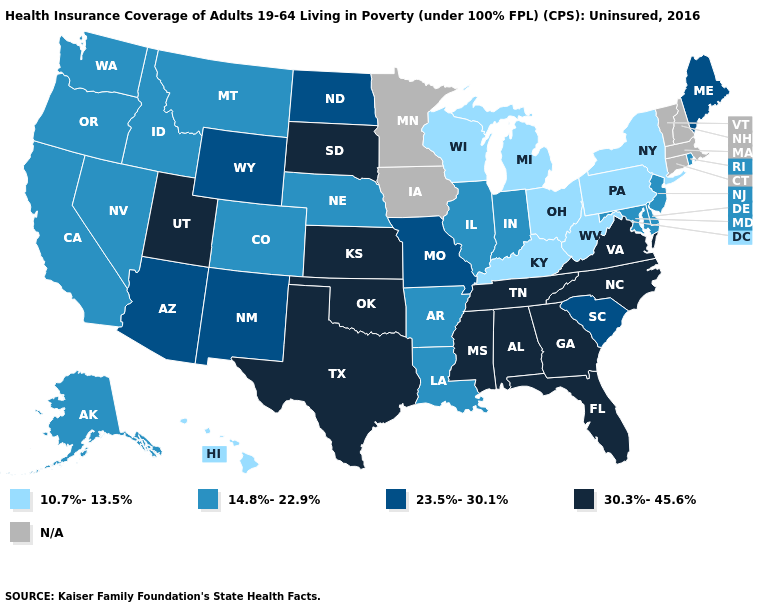What is the highest value in the USA?
Be succinct. 30.3%-45.6%. Does Alaska have the highest value in the USA?
Short answer required. No. Name the states that have a value in the range 10.7%-13.5%?
Write a very short answer. Hawaii, Kentucky, Michigan, New York, Ohio, Pennsylvania, West Virginia, Wisconsin. What is the value of Michigan?
Concise answer only. 10.7%-13.5%. What is the value of Kansas?
Give a very brief answer. 30.3%-45.6%. Name the states that have a value in the range 10.7%-13.5%?
Answer briefly. Hawaii, Kentucky, Michigan, New York, Ohio, Pennsylvania, West Virginia, Wisconsin. Among the states that border Texas , which have the lowest value?
Give a very brief answer. Arkansas, Louisiana. What is the highest value in states that border Connecticut?
Answer briefly. 14.8%-22.9%. Name the states that have a value in the range 23.5%-30.1%?
Quick response, please. Arizona, Maine, Missouri, New Mexico, North Dakota, South Carolina, Wyoming. Does Utah have the highest value in the West?
Be succinct. Yes. What is the lowest value in the USA?
Short answer required. 10.7%-13.5%. Name the states that have a value in the range 30.3%-45.6%?
Quick response, please. Alabama, Florida, Georgia, Kansas, Mississippi, North Carolina, Oklahoma, South Dakota, Tennessee, Texas, Utah, Virginia. Among the states that border Virginia , which have the highest value?
Keep it brief. North Carolina, Tennessee. Which states have the lowest value in the MidWest?
Answer briefly. Michigan, Ohio, Wisconsin. How many symbols are there in the legend?
Give a very brief answer. 5. 